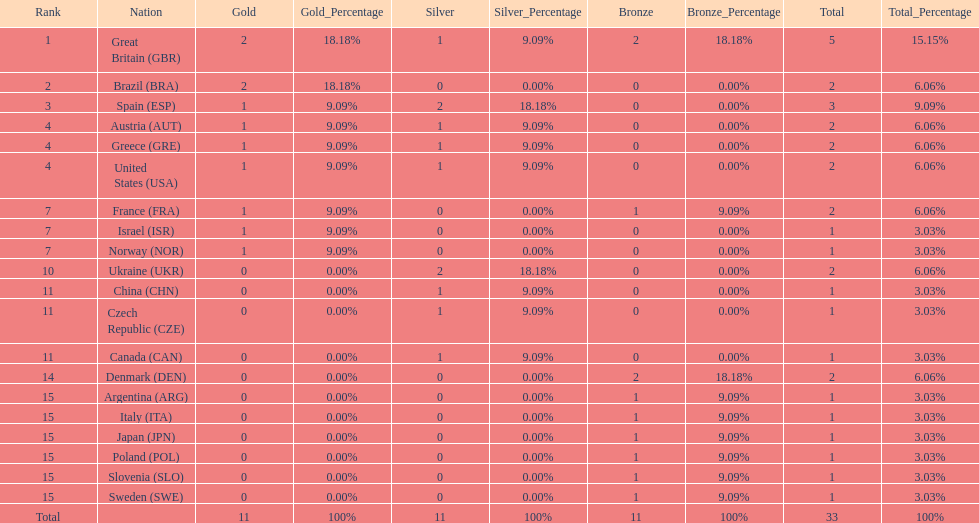What nation was next to great britain in total medal count? Spain. 